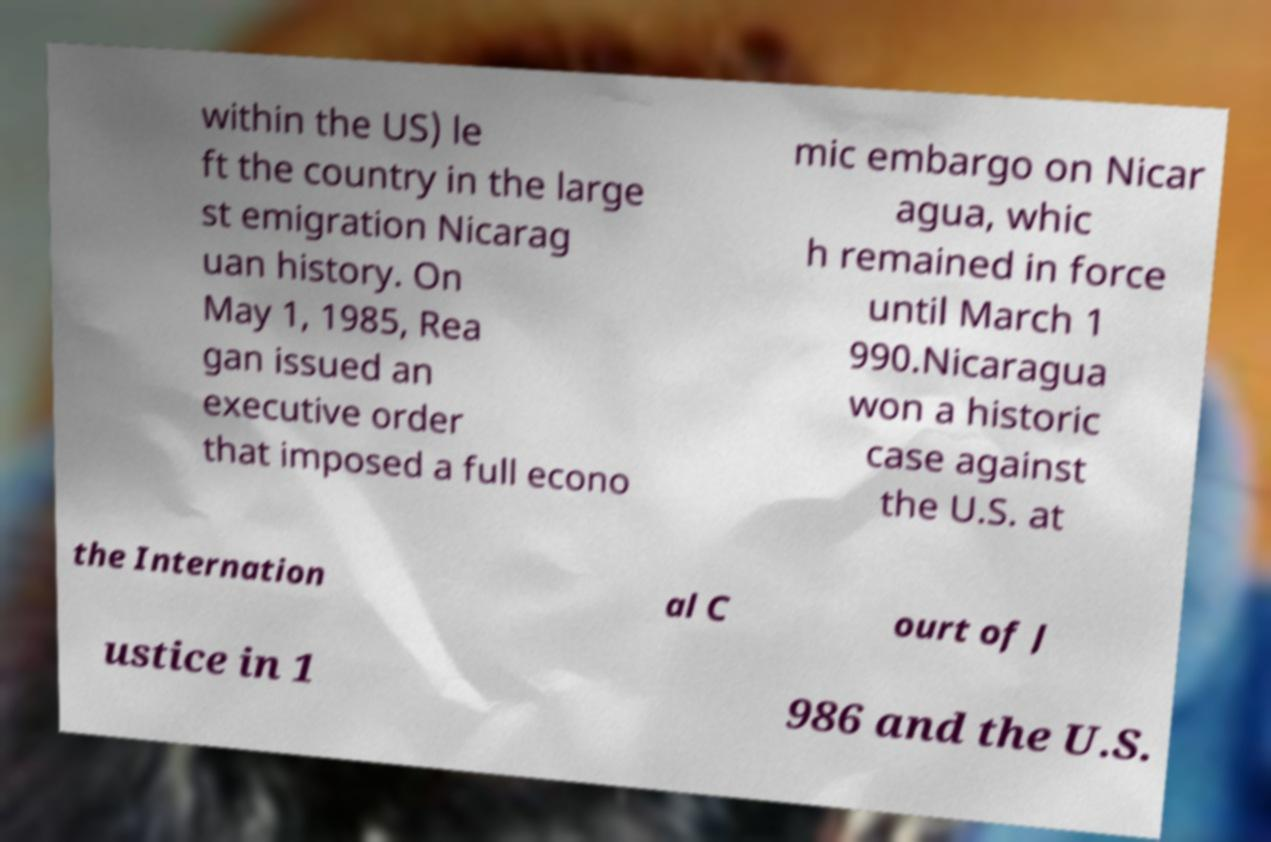Can you accurately transcribe the text from the provided image for me? within the US) le ft the country in the large st emigration Nicarag uan history. On May 1, 1985, Rea gan issued an executive order that imposed a full econo mic embargo on Nicar agua, whic h remained in force until March 1 990.Nicaragua won a historic case against the U.S. at the Internation al C ourt of J ustice in 1 986 and the U.S. 